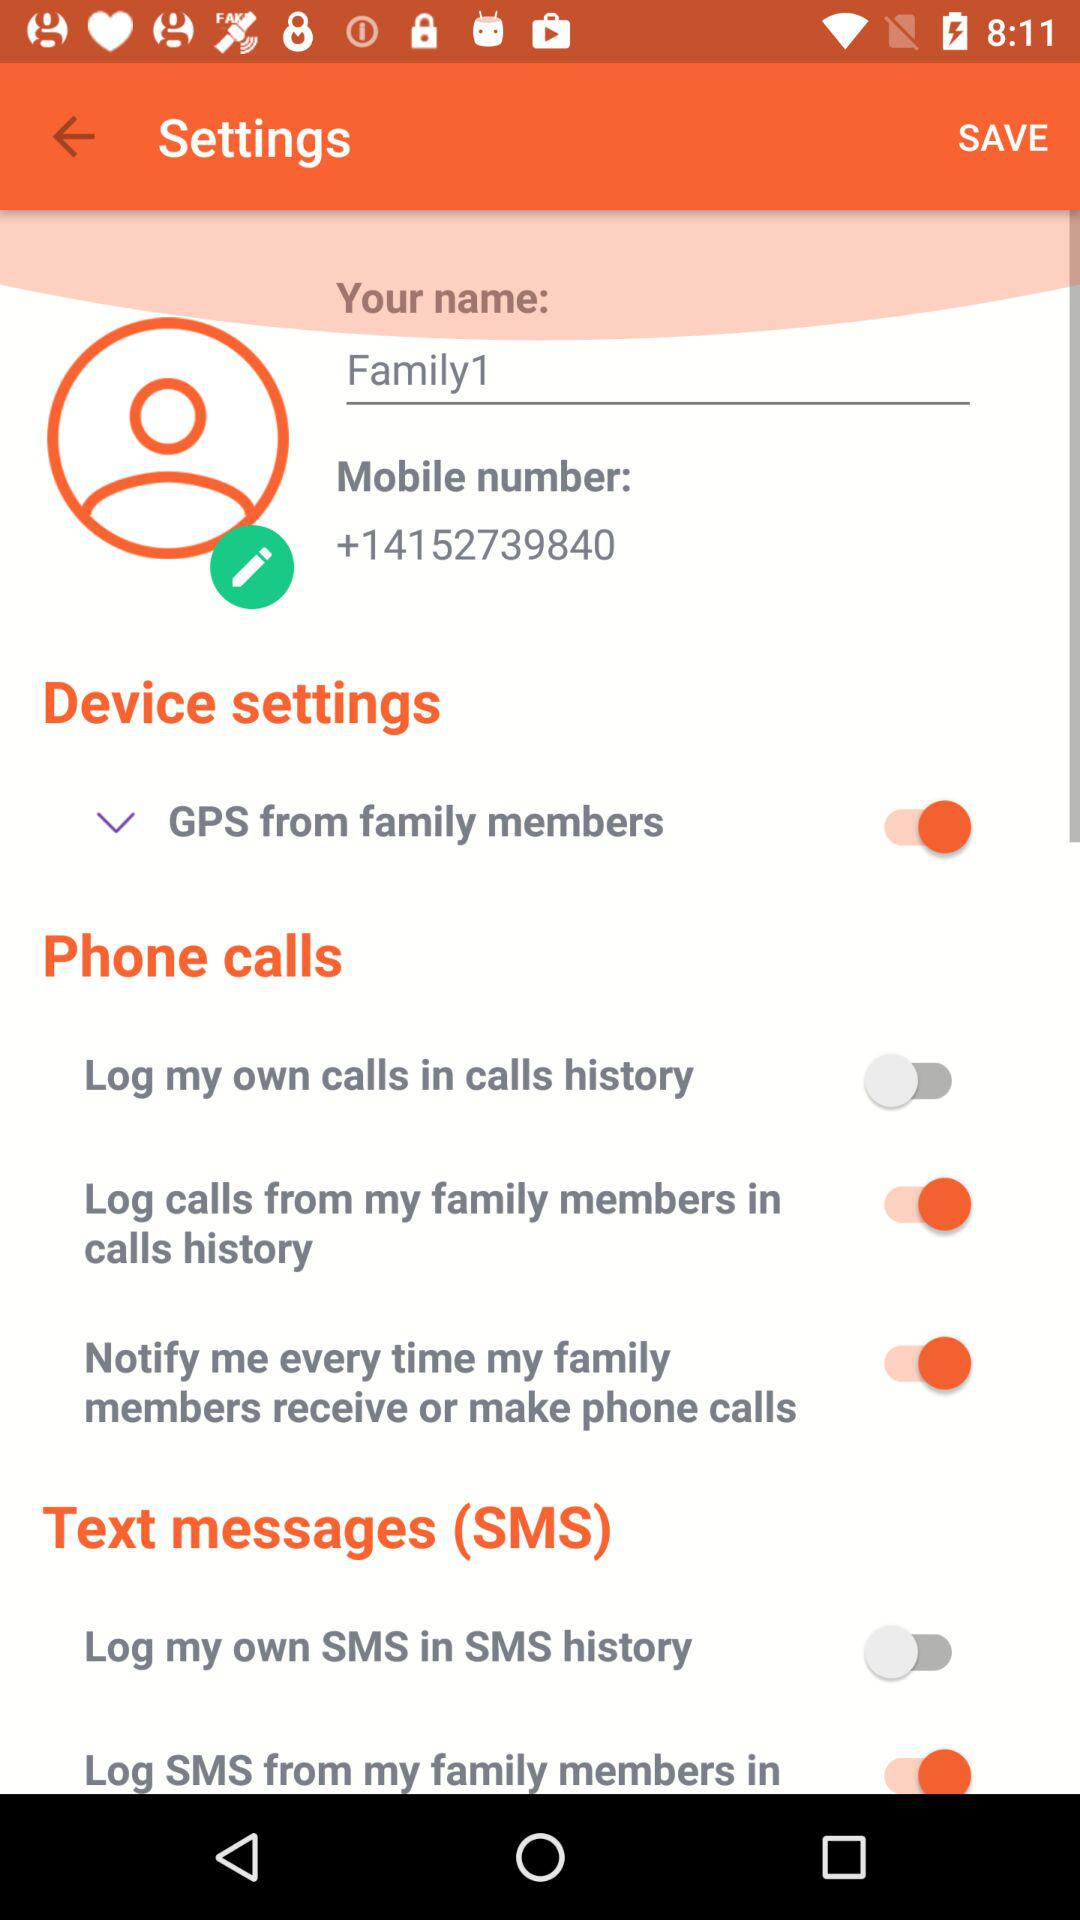What is the mobile number? The mobile number is +14152739840. 